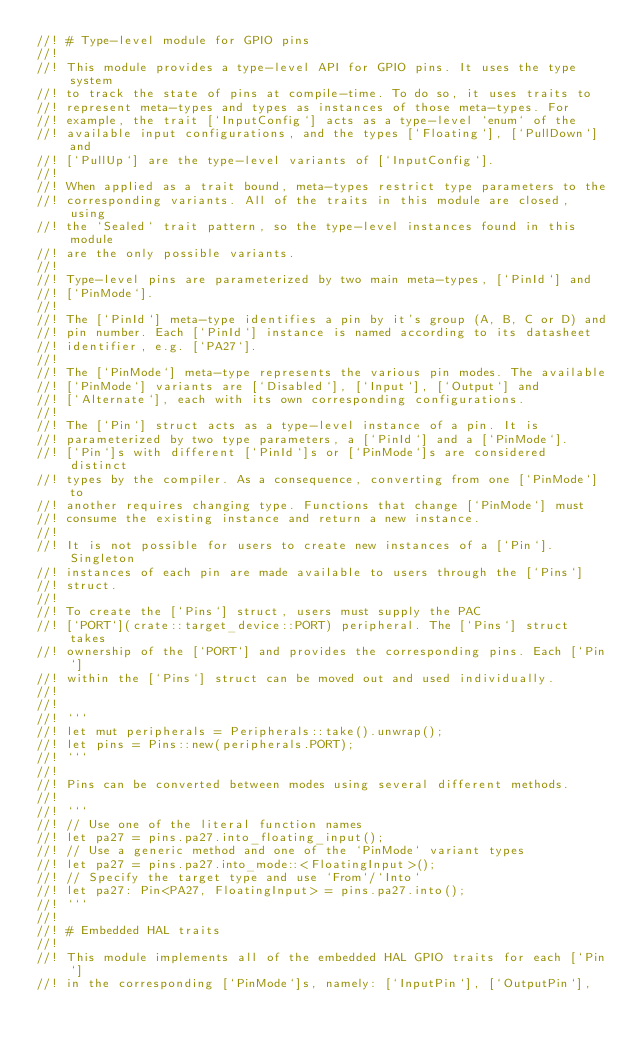Convert code to text. <code><loc_0><loc_0><loc_500><loc_500><_Rust_>//! # Type-level module for GPIO pins
//!
//! This module provides a type-level API for GPIO pins. It uses the type system
//! to track the state of pins at compile-time. To do so, it uses traits to
//! represent meta-types and types as instances of those meta-types. For
//! example, the trait [`InputConfig`] acts as a type-level `enum` of the
//! available input configurations, and the types [`Floating`], [`PullDown`] and
//! [`PullUp`] are the type-level variants of [`InputConfig`].
//!
//! When applied as a trait bound, meta-types restrict type parameters to the
//! corresponding variants. All of the traits in this module are closed, using
//! the `Sealed` trait pattern, so the type-level instances found in this module
//! are the only possible variants.
//!
//! Type-level pins are parameterized by two main meta-types, [`PinId`] and
//! [`PinMode`].
//!
//! The [`PinId`] meta-type identifies a pin by it's group (A, B, C or D) and
//! pin number. Each [`PinId`] instance is named according to its datasheet
//! identifier, e.g. [`PA27`].
//!
//! The [`PinMode`] meta-type represents the various pin modes. The available
//! [`PinMode`] variants are [`Disabled`], [`Input`], [`Output`] and
//! [`Alternate`], each with its own corresponding configurations.
//!
//! The [`Pin`] struct acts as a type-level instance of a pin. It is
//! parameterized by two type parameters, a [`PinId`] and a [`PinMode`].
//! [`Pin`]s with different [`PinId`]s or [`PinMode`]s are considered distinct
//! types by the compiler. As a consequence, converting from one [`PinMode`] to
//! another requires changing type. Functions that change [`PinMode`] must
//! consume the existing instance and return a new instance.
//!
//! It is not possible for users to create new instances of a [`Pin`]. Singleton
//! instances of each pin are made available to users through the [`Pins`]
//! struct.
//!
//! To create the [`Pins`] struct, users must supply the PAC
//! [`PORT`](crate::target_device::PORT) peripheral. The [`Pins`] struct takes
//! ownership of the [`PORT`] and provides the corresponding pins. Each [`Pin`]
//! within the [`Pins`] struct can be moved out and used individually.
//!
//!
//! ```
//! let mut peripherals = Peripherals::take().unwrap();
//! let pins = Pins::new(peripherals.PORT);
//! ```
//!
//! Pins can be converted between modes using several different methods.
//!
//! ```
//! // Use one of the literal function names
//! let pa27 = pins.pa27.into_floating_input();
//! // Use a generic method and one of the `PinMode` variant types
//! let pa27 = pins.pa27.into_mode::<FloatingInput>();
//! // Specify the target type and use `From`/`Into`
//! let pa27: Pin<PA27, FloatingInput> = pins.pa27.into();
//! ```
//!
//! # Embedded HAL traits
//!
//! This module implements all of the embedded HAL GPIO traits for each [`Pin`]
//! in the corresponding [`PinMode`]s, namely: [`InputPin`], [`OutputPin`],</code> 